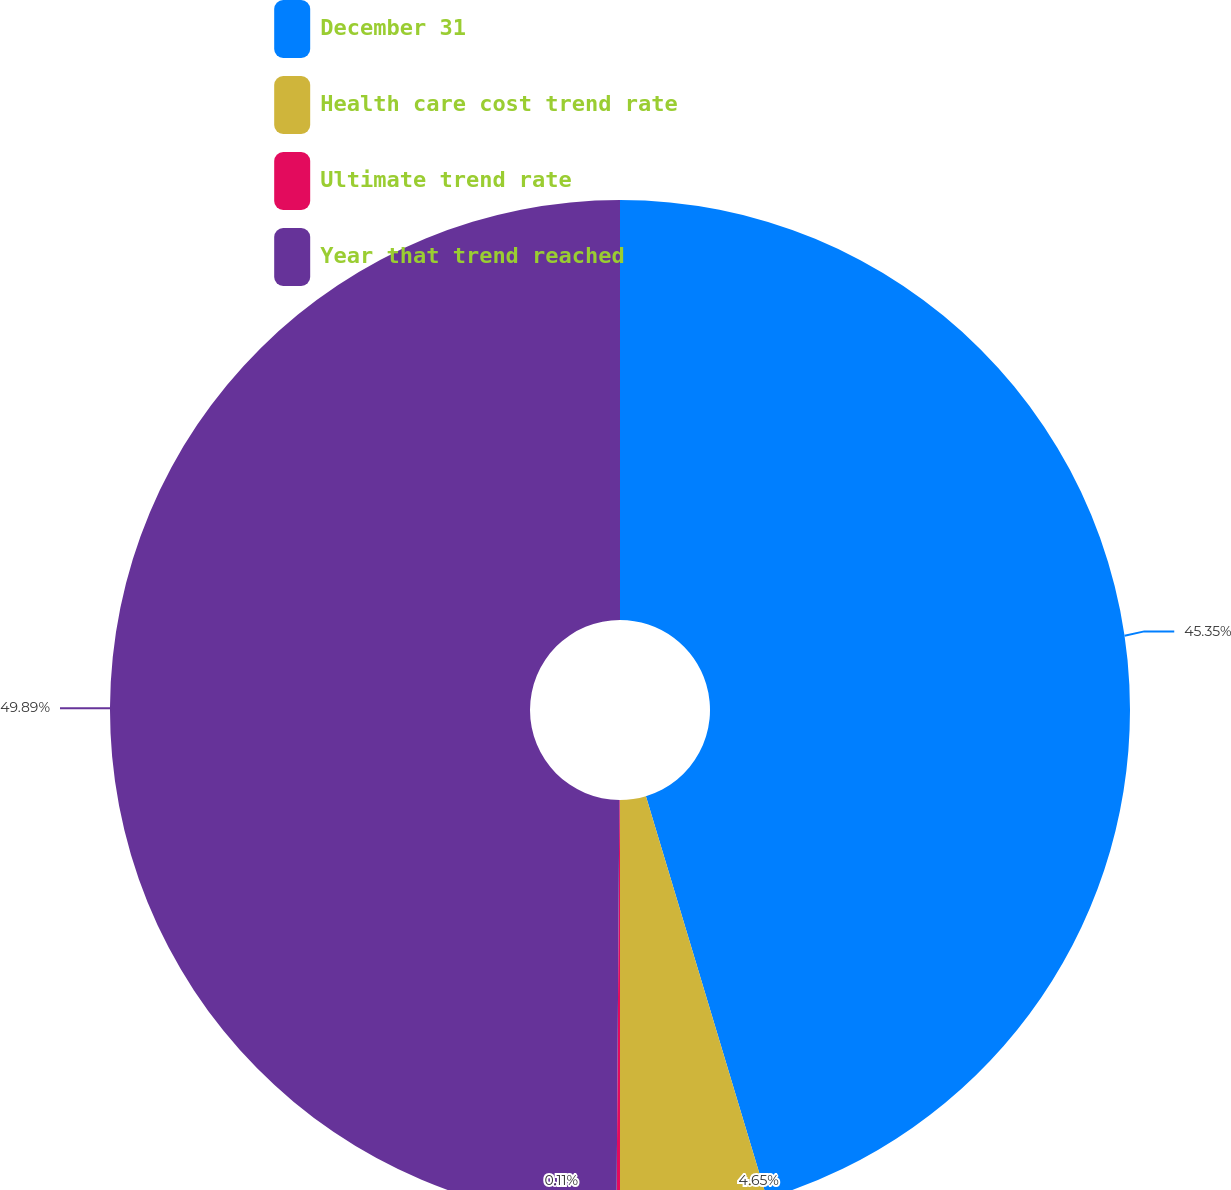Convert chart to OTSL. <chart><loc_0><loc_0><loc_500><loc_500><pie_chart><fcel>December 31<fcel>Health care cost trend rate<fcel>Ultimate trend rate<fcel>Year that trend reached<nl><fcel>45.35%<fcel>4.65%<fcel>0.11%<fcel>49.89%<nl></chart> 